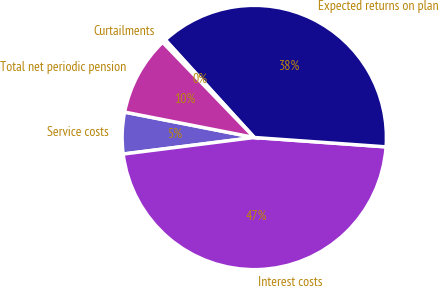Convert chart to OTSL. <chart><loc_0><loc_0><loc_500><loc_500><pie_chart><fcel>Service costs<fcel>Interest costs<fcel>Expected returns on plan<fcel>Curtailments<fcel>Total net periodic pension<nl><fcel>5.08%<fcel>46.87%<fcel>37.89%<fcel>0.44%<fcel>9.72%<nl></chart> 